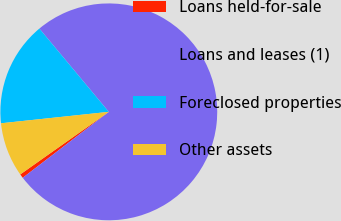Convert chart to OTSL. <chart><loc_0><loc_0><loc_500><loc_500><pie_chart><fcel>Loans held-for-sale<fcel>Loans and leases (1)<fcel>Foreclosed properties<fcel>Other assets<nl><fcel>0.61%<fcel>75.66%<fcel>15.62%<fcel>8.11%<nl></chart> 